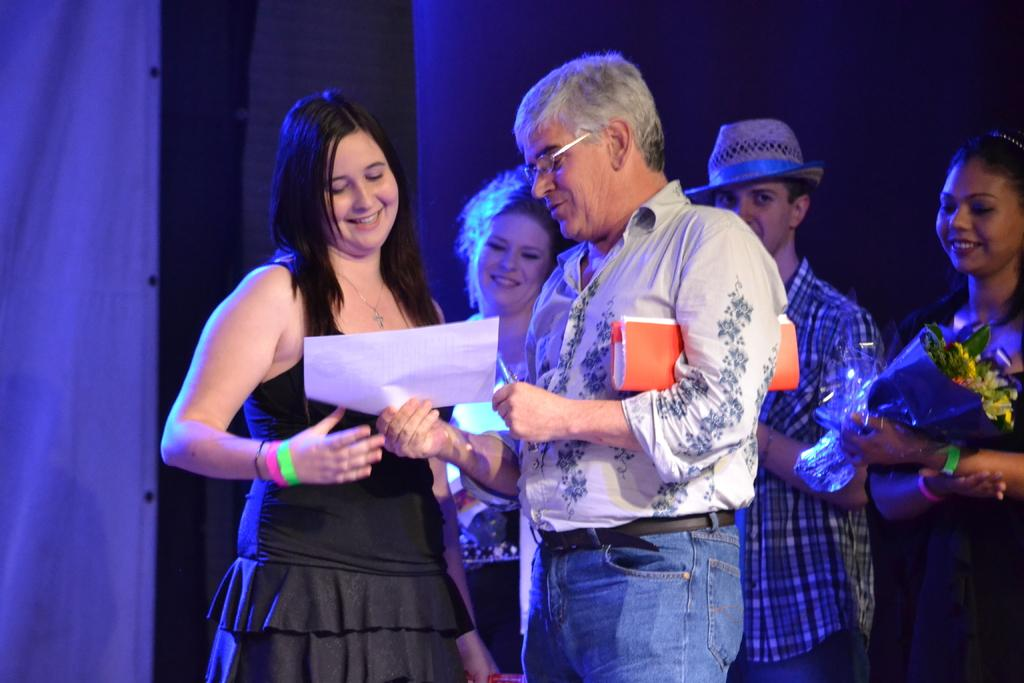What is happening in the image involving the people? There are people standing in the image, and a man is giving a white color paper to a woman. Can you describe the interaction between the man and the woman? The man is handing a white paper to the woman, which suggests a possible exchange of information or documents. What type of patch can be seen on the woman's clothing in the image? There is no patch visible on the woman's clothing in the image. What does the image smell like? The image is a visual representation and does not have a smell. 